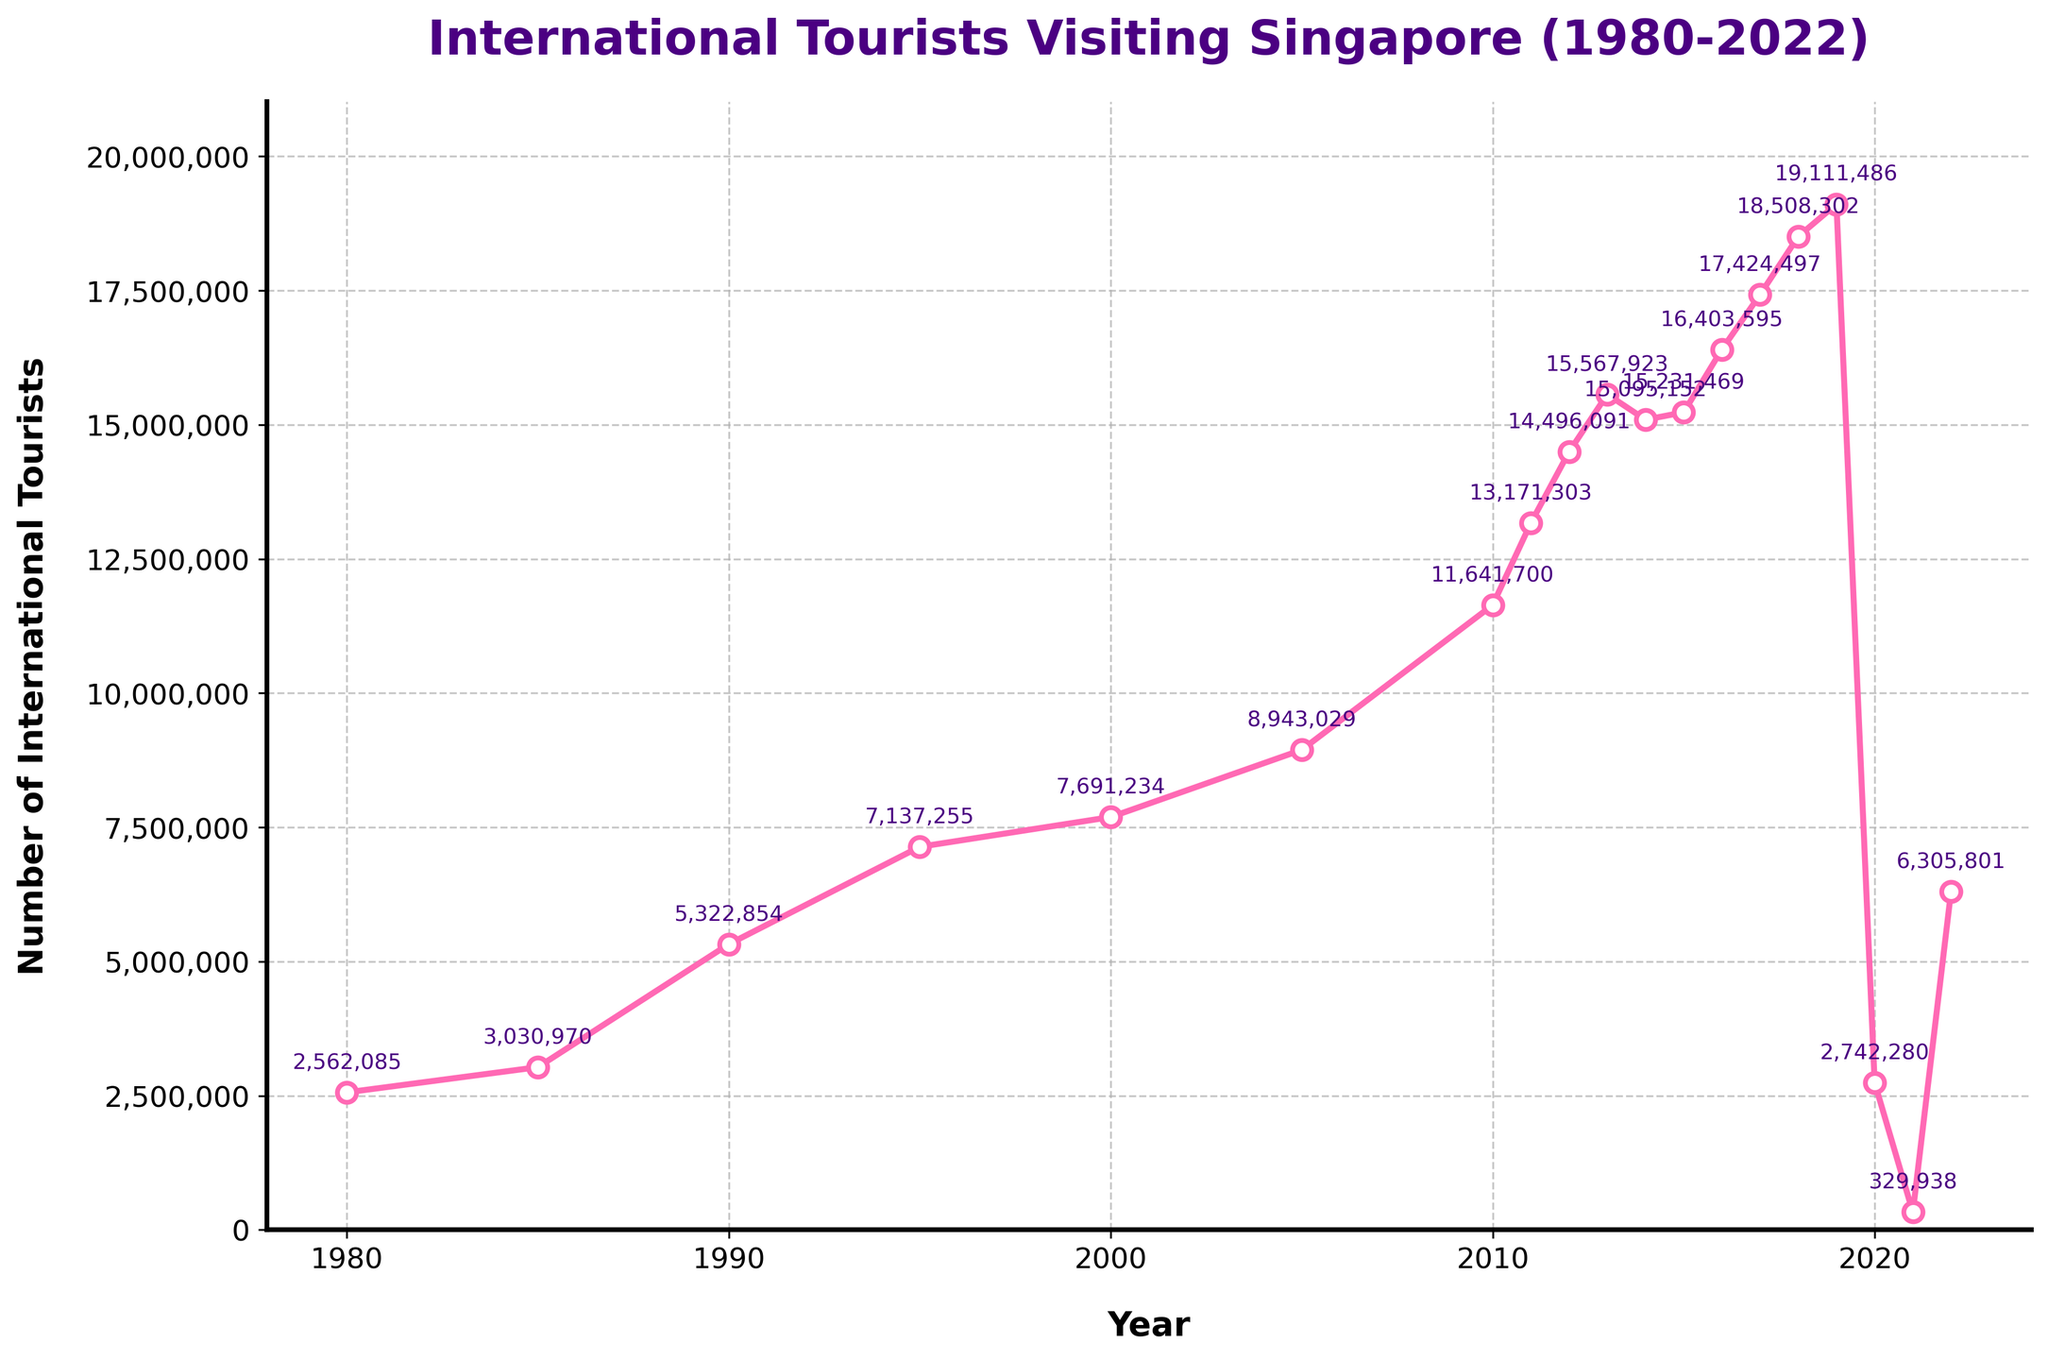What was the number of international tourists in 2019? To find the number of international tourists in 2019, look at the chart and identify the value for the year 2019.
Answer: 19,111,486 What is the difference in the number of international tourists between 1980 and 1990? Look at the values for 1980 and 1990 and subtract the 1980 value from the 1990 value.
Answer: 2,760,769 Which year saw the highest number of international tourists? Identify the year with the highest peak on the chart.
Answer: 2019 Compare the number of international tourists in 2000 and 2005. Which year had more visitors? Look at the values for both years and compare them to see which is higher.
Answer: 2005 What is the average number of international tourists from 2010 to 2015 (inclusive)? Sum the values for each year from 2010 to 2015, then divide by the number of years (6).
Answer: 13,606,194 Between which two consecutive years was the largest decrease in the number of international tourists observed? Identify the largest drop between any two consecutive years by comparing the difference in tourist numbers.
Answer: 2019 to 2020 What is the total number of international tourists who visited Singapore from 1980 to 1985? Add the numbers for the years 1980 and 1985.
Answer: 5,593,055 By how much did the number of international tourists change between 2015 and 2022? Subtract the number in 2015 from the number in 2022.
Answer: -8,601,668 Visually, which years saw a sharp decline in the number of international tourists? Identify years with steep drops by observing the slopes of lines on the chart.
Answer: 2019 to 2020 What are the noticeable trends in the number of international tourists visiting Singapore from 1980 to 2022? Describe the general changes and patterns observed in the chart.
Answer: Overall increase with significant drops in 2020 and 2021 